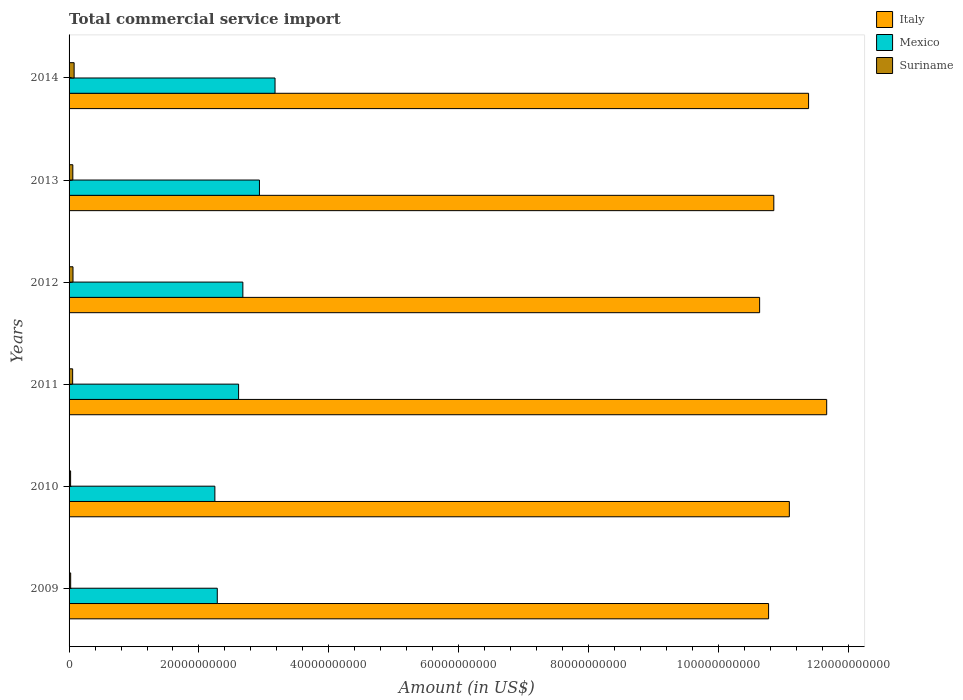How many groups of bars are there?
Provide a succinct answer. 6. How many bars are there on the 2nd tick from the bottom?
Ensure brevity in your answer.  3. What is the label of the 5th group of bars from the top?
Give a very brief answer. 2010. What is the total commercial service import in Suriname in 2011?
Keep it short and to the point. 5.53e+08. Across all years, what is the maximum total commercial service import in Mexico?
Your answer should be compact. 3.17e+1. Across all years, what is the minimum total commercial service import in Mexico?
Offer a very short reply. 2.25e+1. In which year was the total commercial service import in Italy maximum?
Give a very brief answer. 2011. In which year was the total commercial service import in Mexico minimum?
Keep it short and to the point. 2010. What is the total total commercial service import in Suriname in the graph?
Keep it short and to the point. 3.00e+09. What is the difference between the total commercial service import in Italy in 2009 and that in 2013?
Ensure brevity in your answer.  -8.05e+08. What is the difference between the total commercial service import in Mexico in 2014 and the total commercial service import in Italy in 2012?
Ensure brevity in your answer.  -7.46e+1. What is the average total commercial service import in Suriname per year?
Your answer should be compact. 5.00e+08. In the year 2013, what is the difference between the total commercial service import in Mexico and total commercial service import in Suriname?
Your answer should be very brief. 2.87e+1. In how many years, is the total commercial service import in Italy greater than 28000000000 US$?
Make the answer very short. 6. What is the ratio of the total commercial service import in Italy in 2010 to that in 2014?
Make the answer very short. 0.97. Is the difference between the total commercial service import in Mexico in 2012 and 2013 greater than the difference between the total commercial service import in Suriname in 2012 and 2013?
Give a very brief answer. No. What is the difference between the highest and the second highest total commercial service import in Suriname?
Ensure brevity in your answer.  1.75e+08. What is the difference between the highest and the lowest total commercial service import in Italy?
Give a very brief answer. 1.03e+1. Is the sum of the total commercial service import in Italy in 2013 and 2014 greater than the maximum total commercial service import in Mexico across all years?
Your response must be concise. Yes. What does the 1st bar from the top in 2012 represents?
Your answer should be compact. Suriname. What does the 1st bar from the bottom in 2011 represents?
Provide a succinct answer. Italy. Is it the case that in every year, the sum of the total commercial service import in Suriname and total commercial service import in Italy is greater than the total commercial service import in Mexico?
Offer a terse response. Yes. How many bars are there?
Your response must be concise. 18. Are all the bars in the graph horizontal?
Your answer should be compact. Yes. How many years are there in the graph?
Your answer should be compact. 6. Are the values on the major ticks of X-axis written in scientific E-notation?
Make the answer very short. No. Does the graph contain any zero values?
Ensure brevity in your answer.  No. Does the graph contain grids?
Provide a succinct answer. No. How many legend labels are there?
Ensure brevity in your answer.  3. How are the legend labels stacked?
Ensure brevity in your answer.  Vertical. What is the title of the graph?
Your response must be concise. Total commercial service import. Does "Montenegro" appear as one of the legend labels in the graph?
Give a very brief answer. No. What is the label or title of the X-axis?
Offer a terse response. Amount (in US$). What is the Amount (in US$) in Italy in 2009?
Give a very brief answer. 1.08e+11. What is the Amount (in US$) in Mexico in 2009?
Make the answer very short. 2.28e+1. What is the Amount (in US$) in Suriname in 2009?
Provide a short and direct response. 2.46e+08. What is the Amount (in US$) of Italy in 2010?
Ensure brevity in your answer.  1.11e+11. What is the Amount (in US$) of Mexico in 2010?
Your response must be concise. 2.25e+1. What is the Amount (in US$) of Suriname in 2010?
Make the answer very short. 2.37e+08. What is the Amount (in US$) in Italy in 2011?
Make the answer very short. 1.17e+11. What is the Amount (in US$) of Mexico in 2011?
Your response must be concise. 2.61e+1. What is the Amount (in US$) of Suriname in 2011?
Ensure brevity in your answer.  5.53e+08. What is the Amount (in US$) in Italy in 2012?
Provide a succinct answer. 1.06e+11. What is the Amount (in US$) of Mexico in 2012?
Make the answer very short. 2.68e+1. What is the Amount (in US$) in Suriname in 2012?
Make the answer very short. 6.05e+08. What is the Amount (in US$) in Italy in 2013?
Offer a very short reply. 1.09e+11. What is the Amount (in US$) in Mexico in 2013?
Your answer should be compact. 2.93e+1. What is the Amount (in US$) in Suriname in 2013?
Your answer should be very brief. 5.78e+08. What is the Amount (in US$) in Italy in 2014?
Your answer should be compact. 1.14e+11. What is the Amount (in US$) of Mexico in 2014?
Offer a very short reply. 3.17e+1. What is the Amount (in US$) of Suriname in 2014?
Offer a terse response. 7.79e+08. Across all years, what is the maximum Amount (in US$) in Italy?
Your response must be concise. 1.17e+11. Across all years, what is the maximum Amount (in US$) of Mexico?
Your response must be concise. 3.17e+1. Across all years, what is the maximum Amount (in US$) of Suriname?
Offer a very short reply. 7.79e+08. Across all years, what is the minimum Amount (in US$) of Italy?
Offer a terse response. 1.06e+11. Across all years, what is the minimum Amount (in US$) of Mexico?
Keep it short and to the point. 2.25e+1. Across all years, what is the minimum Amount (in US$) in Suriname?
Give a very brief answer. 2.37e+08. What is the total Amount (in US$) of Italy in the graph?
Ensure brevity in your answer.  6.64e+11. What is the total Amount (in US$) in Mexico in the graph?
Keep it short and to the point. 1.59e+11. What is the total Amount (in US$) in Suriname in the graph?
Provide a short and direct response. 3.00e+09. What is the difference between the Amount (in US$) in Italy in 2009 and that in 2010?
Your answer should be very brief. -3.20e+09. What is the difference between the Amount (in US$) in Mexico in 2009 and that in 2010?
Offer a terse response. 3.72e+08. What is the difference between the Amount (in US$) in Suriname in 2009 and that in 2010?
Offer a very short reply. 8.30e+06. What is the difference between the Amount (in US$) in Italy in 2009 and that in 2011?
Offer a terse response. -8.95e+09. What is the difference between the Amount (in US$) in Mexico in 2009 and that in 2011?
Ensure brevity in your answer.  -3.28e+09. What is the difference between the Amount (in US$) in Suriname in 2009 and that in 2011?
Keep it short and to the point. -3.07e+08. What is the difference between the Amount (in US$) of Italy in 2009 and that in 2012?
Ensure brevity in your answer.  1.38e+09. What is the difference between the Amount (in US$) of Mexico in 2009 and that in 2012?
Keep it short and to the point. -3.94e+09. What is the difference between the Amount (in US$) in Suriname in 2009 and that in 2012?
Provide a succinct answer. -3.59e+08. What is the difference between the Amount (in US$) in Italy in 2009 and that in 2013?
Your answer should be very brief. -8.05e+08. What is the difference between the Amount (in US$) in Mexico in 2009 and that in 2013?
Provide a succinct answer. -6.49e+09. What is the difference between the Amount (in US$) of Suriname in 2009 and that in 2013?
Your answer should be very brief. -3.33e+08. What is the difference between the Amount (in US$) in Italy in 2009 and that in 2014?
Your response must be concise. -6.16e+09. What is the difference between the Amount (in US$) in Mexico in 2009 and that in 2014?
Your answer should be compact. -8.89e+09. What is the difference between the Amount (in US$) of Suriname in 2009 and that in 2014?
Give a very brief answer. -5.34e+08. What is the difference between the Amount (in US$) in Italy in 2010 and that in 2011?
Keep it short and to the point. -5.75e+09. What is the difference between the Amount (in US$) of Mexico in 2010 and that in 2011?
Keep it short and to the point. -3.65e+09. What is the difference between the Amount (in US$) in Suriname in 2010 and that in 2011?
Provide a short and direct response. -3.15e+08. What is the difference between the Amount (in US$) of Italy in 2010 and that in 2012?
Make the answer very short. 4.58e+09. What is the difference between the Amount (in US$) in Mexico in 2010 and that in 2012?
Provide a succinct answer. -4.31e+09. What is the difference between the Amount (in US$) of Suriname in 2010 and that in 2012?
Your answer should be compact. -3.68e+08. What is the difference between the Amount (in US$) in Italy in 2010 and that in 2013?
Give a very brief answer. 2.39e+09. What is the difference between the Amount (in US$) in Mexico in 2010 and that in 2013?
Your answer should be compact. -6.86e+09. What is the difference between the Amount (in US$) of Suriname in 2010 and that in 2013?
Your answer should be compact. -3.41e+08. What is the difference between the Amount (in US$) in Italy in 2010 and that in 2014?
Your answer should be very brief. -2.96e+09. What is the difference between the Amount (in US$) in Mexico in 2010 and that in 2014?
Offer a terse response. -9.26e+09. What is the difference between the Amount (in US$) in Suriname in 2010 and that in 2014?
Keep it short and to the point. -5.42e+08. What is the difference between the Amount (in US$) in Italy in 2011 and that in 2012?
Offer a very short reply. 1.03e+1. What is the difference between the Amount (in US$) of Mexico in 2011 and that in 2012?
Keep it short and to the point. -6.57e+08. What is the difference between the Amount (in US$) in Suriname in 2011 and that in 2012?
Make the answer very short. -5.22e+07. What is the difference between the Amount (in US$) in Italy in 2011 and that in 2013?
Your answer should be very brief. 8.14e+09. What is the difference between the Amount (in US$) in Mexico in 2011 and that in 2013?
Your answer should be compact. -3.21e+09. What is the difference between the Amount (in US$) of Suriname in 2011 and that in 2013?
Provide a short and direct response. -2.56e+07. What is the difference between the Amount (in US$) in Italy in 2011 and that in 2014?
Offer a terse response. 2.79e+09. What is the difference between the Amount (in US$) of Mexico in 2011 and that in 2014?
Your answer should be very brief. -5.61e+09. What is the difference between the Amount (in US$) of Suriname in 2011 and that in 2014?
Offer a terse response. -2.27e+08. What is the difference between the Amount (in US$) of Italy in 2012 and that in 2013?
Give a very brief answer. -2.18e+09. What is the difference between the Amount (in US$) of Mexico in 2012 and that in 2013?
Ensure brevity in your answer.  -2.55e+09. What is the difference between the Amount (in US$) of Suriname in 2012 and that in 2013?
Keep it short and to the point. 2.66e+07. What is the difference between the Amount (in US$) in Italy in 2012 and that in 2014?
Ensure brevity in your answer.  -7.54e+09. What is the difference between the Amount (in US$) of Mexico in 2012 and that in 2014?
Your answer should be compact. -4.95e+09. What is the difference between the Amount (in US$) of Suriname in 2012 and that in 2014?
Make the answer very short. -1.75e+08. What is the difference between the Amount (in US$) in Italy in 2013 and that in 2014?
Give a very brief answer. -5.35e+09. What is the difference between the Amount (in US$) of Mexico in 2013 and that in 2014?
Offer a terse response. -2.40e+09. What is the difference between the Amount (in US$) in Suriname in 2013 and that in 2014?
Provide a succinct answer. -2.01e+08. What is the difference between the Amount (in US$) in Italy in 2009 and the Amount (in US$) in Mexico in 2010?
Offer a very short reply. 8.53e+1. What is the difference between the Amount (in US$) of Italy in 2009 and the Amount (in US$) of Suriname in 2010?
Make the answer very short. 1.07e+11. What is the difference between the Amount (in US$) of Mexico in 2009 and the Amount (in US$) of Suriname in 2010?
Your answer should be compact. 2.26e+1. What is the difference between the Amount (in US$) in Italy in 2009 and the Amount (in US$) in Mexico in 2011?
Offer a terse response. 8.16e+1. What is the difference between the Amount (in US$) in Italy in 2009 and the Amount (in US$) in Suriname in 2011?
Give a very brief answer. 1.07e+11. What is the difference between the Amount (in US$) of Mexico in 2009 and the Amount (in US$) of Suriname in 2011?
Your answer should be very brief. 2.23e+1. What is the difference between the Amount (in US$) of Italy in 2009 and the Amount (in US$) of Mexico in 2012?
Your answer should be compact. 8.10e+1. What is the difference between the Amount (in US$) in Italy in 2009 and the Amount (in US$) in Suriname in 2012?
Offer a terse response. 1.07e+11. What is the difference between the Amount (in US$) of Mexico in 2009 and the Amount (in US$) of Suriname in 2012?
Provide a succinct answer. 2.22e+1. What is the difference between the Amount (in US$) of Italy in 2009 and the Amount (in US$) of Mexico in 2013?
Your response must be concise. 7.84e+1. What is the difference between the Amount (in US$) in Italy in 2009 and the Amount (in US$) in Suriname in 2013?
Ensure brevity in your answer.  1.07e+11. What is the difference between the Amount (in US$) of Mexico in 2009 and the Amount (in US$) of Suriname in 2013?
Provide a short and direct response. 2.22e+1. What is the difference between the Amount (in US$) of Italy in 2009 and the Amount (in US$) of Mexico in 2014?
Your answer should be compact. 7.60e+1. What is the difference between the Amount (in US$) of Italy in 2009 and the Amount (in US$) of Suriname in 2014?
Provide a short and direct response. 1.07e+11. What is the difference between the Amount (in US$) of Mexico in 2009 and the Amount (in US$) of Suriname in 2014?
Offer a very short reply. 2.20e+1. What is the difference between the Amount (in US$) of Italy in 2010 and the Amount (in US$) of Mexico in 2011?
Your answer should be very brief. 8.48e+1. What is the difference between the Amount (in US$) of Italy in 2010 and the Amount (in US$) of Suriname in 2011?
Provide a succinct answer. 1.10e+11. What is the difference between the Amount (in US$) in Mexico in 2010 and the Amount (in US$) in Suriname in 2011?
Make the answer very short. 2.19e+1. What is the difference between the Amount (in US$) in Italy in 2010 and the Amount (in US$) in Mexico in 2012?
Offer a terse response. 8.41e+1. What is the difference between the Amount (in US$) of Italy in 2010 and the Amount (in US$) of Suriname in 2012?
Make the answer very short. 1.10e+11. What is the difference between the Amount (in US$) in Mexico in 2010 and the Amount (in US$) in Suriname in 2012?
Make the answer very short. 2.18e+1. What is the difference between the Amount (in US$) of Italy in 2010 and the Amount (in US$) of Mexico in 2013?
Provide a short and direct response. 8.16e+1. What is the difference between the Amount (in US$) in Italy in 2010 and the Amount (in US$) in Suriname in 2013?
Make the answer very short. 1.10e+11. What is the difference between the Amount (in US$) of Mexico in 2010 and the Amount (in US$) of Suriname in 2013?
Your answer should be compact. 2.19e+1. What is the difference between the Amount (in US$) in Italy in 2010 and the Amount (in US$) in Mexico in 2014?
Keep it short and to the point. 7.92e+1. What is the difference between the Amount (in US$) of Italy in 2010 and the Amount (in US$) of Suriname in 2014?
Your response must be concise. 1.10e+11. What is the difference between the Amount (in US$) of Mexico in 2010 and the Amount (in US$) of Suriname in 2014?
Provide a short and direct response. 2.17e+1. What is the difference between the Amount (in US$) in Italy in 2011 and the Amount (in US$) in Mexico in 2012?
Give a very brief answer. 8.99e+1. What is the difference between the Amount (in US$) in Italy in 2011 and the Amount (in US$) in Suriname in 2012?
Provide a short and direct response. 1.16e+11. What is the difference between the Amount (in US$) in Mexico in 2011 and the Amount (in US$) in Suriname in 2012?
Ensure brevity in your answer.  2.55e+1. What is the difference between the Amount (in US$) in Italy in 2011 and the Amount (in US$) in Mexico in 2013?
Your answer should be compact. 8.73e+1. What is the difference between the Amount (in US$) of Italy in 2011 and the Amount (in US$) of Suriname in 2013?
Offer a very short reply. 1.16e+11. What is the difference between the Amount (in US$) of Mexico in 2011 and the Amount (in US$) of Suriname in 2013?
Your response must be concise. 2.55e+1. What is the difference between the Amount (in US$) of Italy in 2011 and the Amount (in US$) of Mexico in 2014?
Provide a short and direct response. 8.49e+1. What is the difference between the Amount (in US$) of Italy in 2011 and the Amount (in US$) of Suriname in 2014?
Provide a short and direct response. 1.16e+11. What is the difference between the Amount (in US$) of Mexico in 2011 and the Amount (in US$) of Suriname in 2014?
Give a very brief answer. 2.53e+1. What is the difference between the Amount (in US$) in Italy in 2012 and the Amount (in US$) in Mexico in 2013?
Your answer should be compact. 7.70e+1. What is the difference between the Amount (in US$) of Italy in 2012 and the Amount (in US$) of Suriname in 2013?
Ensure brevity in your answer.  1.06e+11. What is the difference between the Amount (in US$) in Mexico in 2012 and the Amount (in US$) in Suriname in 2013?
Provide a succinct answer. 2.62e+1. What is the difference between the Amount (in US$) of Italy in 2012 and the Amount (in US$) of Mexico in 2014?
Ensure brevity in your answer.  7.46e+1. What is the difference between the Amount (in US$) of Italy in 2012 and the Amount (in US$) of Suriname in 2014?
Offer a very short reply. 1.06e+11. What is the difference between the Amount (in US$) of Mexico in 2012 and the Amount (in US$) of Suriname in 2014?
Make the answer very short. 2.60e+1. What is the difference between the Amount (in US$) of Italy in 2013 and the Amount (in US$) of Mexico in 2014?
Make the answer very short. 7.68e+1. What is the difference between the Amount (in US$) of Italy in 2013 and the Amount (in US$) of Suriname in 2014?
Provide a succinct answer. 1.08e+11. What is the difference between the Amount (in US$) in Mexico in 2013 and the Amount (in US$) in Suriname in 2014?
Give a very brief answer. 2.85e+1. What is the average Amount (in US$) in Italy per year?
Ensure brevity in your answer.  1.11e+11. What is the average Amount (in US$) of Mexico per year?
Offer a very short reply. 2.65e+1. What is the average Amount (in US$) in Suriname per year?
Ensure brevity in your answer.  5.00e+08. In the year 2009, what is the difference between the Amount (in US$) of Italy and Amount (in US$) of Mexico?
Ensure brevity in your answer.  8.49e+1. In the year 2009, what is the difference between the Amount (in US$) of Italy and Amount (in US$) of Suriname?
Provide a short and direct response. 1.07e+11. In the year 2009, what is the difference between the Amount (in US$) of Mexico and Amount (in US$) of Suriname?
Your answer should be compact. 2.26e+1. In the year 2010, what is the difference between the Amount (in US$) in Italy and Amount (in US$) in Mexico?
Keep it short and to the point. 8.85e+1. In the year 2010, what is the difference between the Amount (in US$) of Italy and Amount (in US$) of Suriname?
Make the answer very short. 1.11e+11. In the year 2010, what is the difference between the Amount (in US$) of Mexico and Amount (in US$) of Suriname?
Make the answer very short. 2.22e+1. In the year 2011, what is the difference between the Amount (in US$) in Italy and Amount (in US$) in Mexico?
Ensure brevity in your answer.  9.06e+1. In the year 2011, what is the difference between the Amount (in US$) in Italy and Amount (in US$) in Suriname?
Ensure brevity in your answer.  1.16e+11. In the year 2011, what is the difference between the Amount (in US$) of Mexico and Amount (in US$) of Suriname?
Ensure brevity in your answer.  2.56e+1. In the year 2012, what is the difference between the Amount (in US$) in Italy and Amount (in US$) in Mexico?
Offer a very short reply. 7.96e+1. In the year 2012, what is the difference between the Amount (in US$) of Italy and Amount (in US$) of Suriname?
Provide a short and direct response. 1.06e+11. In the year 2012, what is the difference between the Amount (in US$) of Mexico and Amount (in US$) of Suriname?
Provide a short and direct response. 2.62e+1. In the year 2013, what is the difference between the Amount (in US$) in Italy and Amount (in US$) in Mexico?
Provide a succinct answer. 7.92e+1. In the year 2013, what is the difference between the Amount (in US$) of Italy and Amount (in US$) of Suriname?
Provide a short and direct response. 1.08e+11. In the year 2013, what is the difference between the Amount (in US$) in Mexico and Amount (in US$) in Suriname?
Keep it short and to the point. 2.87e+1. In the year 2014, what is the difference between the Amount (in US$) in Italy and Amount (in US$) in Mexico?
Provide a succinct answer. 8.22e+1. In the year 2014, what is the difference between the Amount (in US$) in Italy and Amount (in US$) in Suriname?
Offer a very short reply. 1.13e+11. In the year 2014, what is the difference between the Amount (in US$) of Mexico and Amount (in US$) of Suriname?
Offer a very short reply. 3.09e+1. What is the ratio of the Amount (in US$) of Italy in 2009 to that in 2010?
Provide a short and direct response. 0.97. What is the ratio of the Amount (in US$) in Mexico in 2009 to that in 2010?
Keep it short and to the point. 1.02. What is the ratio of the Amount (in US$) of Suriname in 2009 to that in 2010?
Make the answer very short. 1.03. What is the ratio of the Amount (in US$) of Italy in 2009 to that in 2011?
Your response must be concise. 0.92. What is the ratio of the Amount (in US$) of Mexico in 2009 to that in 2011?
Give a very brief answer. 0.87. What is the ratio of the Amount (in US$) in Suriname in 2009 to that in 2011?
Give a very brief answer. 0.44. What is the ratio of the Amount (in US$) of Italy in 2009 to that in 2012?
Your answer should be very brief. 1.01. What is the ratio of the Amount (in US$) in Mexico in 2009 to that in 2012?
Provide a succinct answer. 0.85. What is the ratio of the Amount (in US$) of Suriname in 2009 to that in 2012?
Your response must be concise. 0.41. What is the ratio of the Amount (in US$) of Italy in 2009 to that in 2013?
Your answer should be very brief. 0.99. What is the ratio of the Amount (in US$) of Mexico in 2009 to that in 2013?
Your answer should be compact. 0.78. What is the ratio of the Amount (in US$) of Suriname in 2009 to that in 2013?
Your answer should be compact. 0.42. What is the ratio of the Amount (in US$) in Italy in 2009 to that in 2014?
Your response must be concise. 0.95. What is the ratio of the Amount (in US$) of Mexico in 2009 to that in 2014?
Provide a short and direct response. 0.72. What is the ratio of the Amount (in US$) in Suriname in 2009 to that in 2014?
Offer a very short reply. 0.32. What is the ratio of the Amount (in US$) of Italy in 2010 to that in 2011?
Your answer should be very brief. 0.95. What is the ratio of the Amount (in US$) in Mexico in 2010 to that in 2011?
Keep it short and to the point. 0.86. What is the ratio of the Amount (in US$) of Suriname in 2010 to that in 2011?
Your answer should be very brief. 0.43. What is the ratio of the Amount (in US$) of Italy in 2010 to that in 2012?
Your answer should be compact. 1.04. What is the ratio of the Amount (in US$) of Mexico in 2010 to that in 2012?
Offer a very short reply. 0.84. What is the ratio of the Amount (in US$) of Suriname in 2010 to that in 2012?
Provide a succinct answer. 0.39. What is the ratio of the Amount (in US$) of Mexico in 2010 to that in 2013?
Your response must be concise. 0.77. What is the ratio of the Amount (in US$) in Suriname in 2010 to that in 2013?
Provide a succinct answer. 0.41. What is the ratio of the Amount (in US$) of Italy in 2010 to that in 2014?
Your response must be concise. 0.97. What is the ratio of the Amount (in US$) in Mexico in 2010 to that in 2014?
Provide a succinct answer. 0.71. What is the ratio of the Amount (in US$) in Suriname in 2010 to that in 2014?
Give a very brief answer. 0.3. What is the ratio of the Amount (in US$) of Italy in 2011 to that in 2012?
Give a very brief answer. 1.1. What is the ratio of the Amount (in US$) in Mexico in 2011 to that in 2012?
Offer a very short reply. 0.98. What is the ratio of the Amount (in US$) of Suriname in 2011 to that in 2012?
Give a very brief answer. 0.91. What is the ratio of the Amount (in US$) of Italy in 2011 to that in 2013?
Offer a very short reply. 1.07. What is the ratio of the Amount (in US$) of Mexico in 2011 to that in 2013?
Keep it short and to the point. 0.89. What is the ratio of the Amount (in US$) in Suriname in 2011 to that in 2013?
Your response must be concise. 0.96. What is the ratio of the Amount (in US$) of Italy in 2011 to that in 2014?
Your answer should be compact. 1.02. What is the ratio of the Amount (in US$) of Mexico in 2011 to that in 2014?
Keep it short and to the point. 0.82. What is the ratio of the Amount (in US$) in Suriname in 2011 to that in 2014?
Make the answer very short. 0.71. What is the ratio of the Amount (in US$) in Italy in 2012 to that in 2013?
Offer a very short reply. 0.98. What is the ratio of the Amount (in US$) of Mexico in 2012 to that in 2013?
Offer a very short reply. 0.91. What is the ratio of the Amount (in US$) in Suriname in 2012 to that in 2013?
Keep it short and to the point. 1.05. What is the ratio of the Amount (in US$) of Italy in 2012 to that in 2014?
Give a very brief answer. 0.93. What is the ratio of the Amount (in US$) in Mexico in 2012 to that in 2014?
Provide a succinct answer. 0.84. What is the ratio of the Amount (in US$) in Suriname in 2012 to that in 2014?
Ensure brevity in your answer.  0.78. What is the ratio of the Amount (in US$) of Italy in 2013 to that in 2014?
Provide a short and direct response. 0.95. What is the ratio of the Amount (in US$) in Mexico in 2013 to that in 2014?
Ensure brevity in your answer.  0.92. What is the ratio of the Amount (in US$) of Suriname in 2013 to that in 2014?
Your answer should be very brief. 0.74. What is the difference between the highest and the second highest Amount (in US$) in Italy?
Your answer should be compact. 2.79e+09. What is the difference between the highest and the second highest Amount (in US$) of Mexico?
Your answer should be compact. 2.40e+09. What is the difference between the highest and the second highest Amount (in US$) in Suriname?
Your response must be concise. 1.75e+08. What is the difference between the highest and the lowest Amount (in US$) in Italy?
Provide a short and direct response. 1.03e+1. What is the difference between the highest and the lowest Amount (in US$) in Mexico?
Your answer should be compact. 9.26e+09. What is the difference between the highest and the lowest Amount (in US$) in Suriname?
Keep it short and to the point. 5.42e+08. 